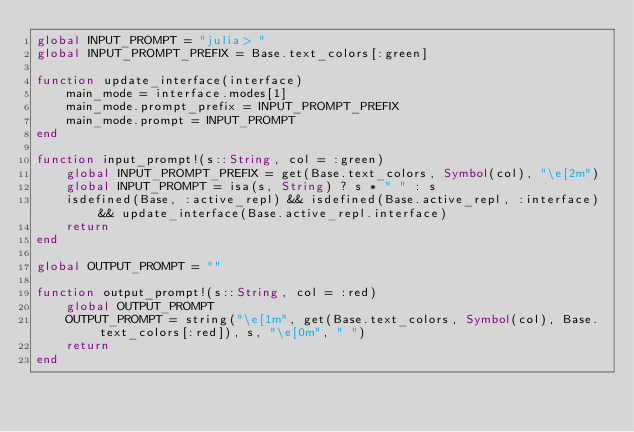<code> <loc_0><loc_0><loc_500><loc_500><_Julia_>global INPUT_PROMPT = "julia> "
global INPUT_PROMPT_PREFIX = Base.text_colors[:green]

function update_interface(interface)
    main_mode = interface.modes[1]
    main_mode.prompt_prefix = INPUT_PROMPT_PREFIX
    main_mode.prompt = INPUT_PROMPT
end

function input_prompt!(s::String, col = :green)
    global INPUT_PROMPT_PREFIX = get(Base.text_colors, Symbol(col), "\e[2m")
    global INPUT_PROMPT = isa(s, String) ? s * " " : s
    isdefined(Base, :active_repl) && isdefined(Base.active_repl, :interface) && update_interface(Base.active_repl.interface)
    return
end

global OUTPUT_PROMPT = ""

function output_prompt!(s::String, col = :red)
    global OUTPUT_PROMPT
    OUTPUT_PROMPT = string("\e[1m", get(Base.text_colors, Symbol(col), Base.text_colors[:red]), s, "\e[0m", " ")
    return
end
</code> 